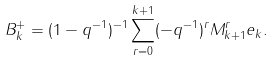<formula> <loc_0><loc_0><loc_500><loc_500>B _ { k } ^ { + } = ( 1 - q ^ { - 1 } ) ^ { - 1 } \sum _ { r = 0 } ^ { k + 1 } ( - q ^ { - 1 } ) ^ { r } M _ { k + 1 } ^ { r } e _ { k } .</formula> 